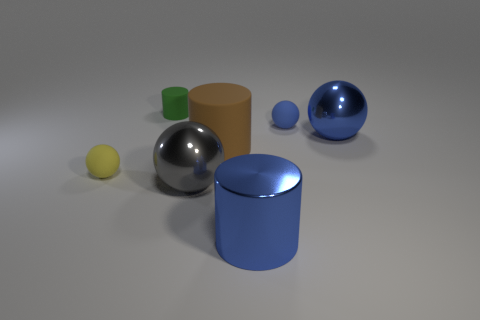Add 1 blue things. How many objects exist? 8 Subtract all red cylinders. Subtract all brown blocks. How many cylinders are left? 3 Subtract all cylinders. How many objects are left? 4 Add 1 blue metallic things. How many blue metallic things are left? 3 Add 6 large rubber blocks. How many large rubber blocks exist? 6 Subtract 1 yellow balls. How many objects are left? 6 Subtract all small cyan rubber cubes. Subtract all large blue balls. How many objects are left? 6 